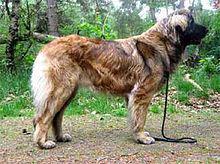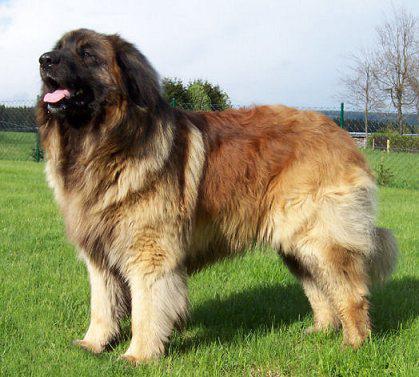The first image is the image on the left, the second image is the image on the right. For the images shown, is this caption "In one image, an adult is standing behind a large dog that has its mouth open." true? Answer yes or no. No. The first image is the image on the left, the second image is the image on the right. Evaluate the accuracy of this statement regarding the images: "there is a child in the image on the left". Is it true? Answer yes or no. No. 